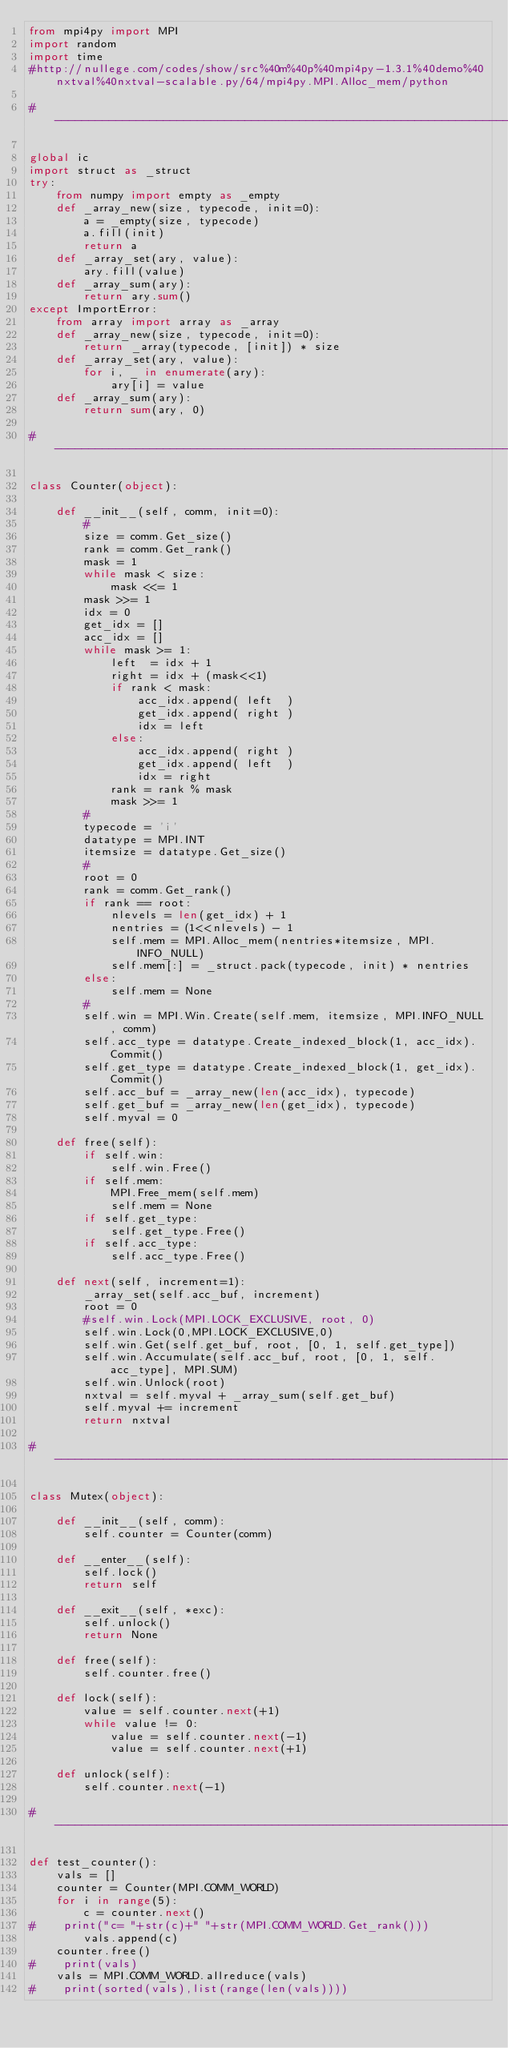Convert code to text. <code><loc_0><loc_0><loc_500><loc_500><_Python_>from mpi4py import MPI
import random
import time
#http://nullege.com/codes/show/src%40m%40p%40mpi4py-1.3.1%40demo%40nxtval%40nxtval-scalable.py/64/mpi4py.MPI.Alloc_mem/python
  
# -----------------------------------------------------------------------------
  
global ic
import struct as _struct
try:
    from numpy import empty as _empty
    def _array_new(size, typecode, init=0):
        a = _empty(size, typecode)
        a.fill(init)
        return a
    def _array_set(ary, value):
        ary.fill(value)
    def _array_sum(ary):
        return ary.sum()
except ImportError:
    from array import array as _array
    def _array_new(size, typecode, init=0):
        return _array(typecode, [init]) * size
    def _array_set(ary, value):
        for i, _ in enumerate(ary):
            ary[i] = value
    def _array_sum(ary):
        return sum(ary, 0)
  
# -----------------------------------------------------------------------------
  
class Counter(object):
  
    def __init__(self, comm, init=0):
        #
        size = comm.Get_size()
        rank = comm.Get_rank()
        mask = 1
        while mask < size:
            mask <<= 1
        mask >>= 1
        idx = 0
        get_idx = []
        acc_idx = []
        while mask >= 1:
            left  = idx + 1
            right = idx + (mask<<1)
            if rank < mask:
                acc_idx.append( left  )
                get_idx.append( right )
                idx = left
            else:
                acc_idx.append( right )
                get_idx.append( left  )
                idx = right
            rank = rank % mask
            mask >>= 1
        #
        typecode = 'i'
        datatype = MPI.INT
        itemsize = datatype.Get_size()
        #
        root = 0
        rank = comm.Get_rank()
        if rank == root:
            nlevels = len(get_idx) + 1
            nentries = (1<<nlevels) - 1
            self.mem = MPI.Alloc_mem(nentries*itemsize, MPI.INFO_NULL)
            self.mem[:] = _struct.pack(typecode, init) * nentries
        else:
            self.mem = None
        #
        self.win = MPI.Win.Create(self.mem, itemsize, MPI.INFO_NULL, comm)
        self.acc_type = datatype.Create_indexed_block(1, acc_idx).Commit()
        self.get_type = datatype.Create_indexed_block(1, get_idx).Commit()
        self.acc_buf = _array_new(len(acc_idx), typecode)
        self.get_buf = _array_new(len(get_idx), typecode)
        self.myval = 0
  
    def free(self):
        if self.win:
            self.win.Free()
        if self.mem:
            MPI.Free_mem(self.mem)
            self.mem = None
        if self.get_type:
            self.get_type.Free()
        if self.acc_type:
            self.acc_type.Free()
  
    def next(self, increment=1):
        _array_set(self.acc_buf, increment)
        root = 0
        #self.win.Lock(MPI.LOCK_EXCLUSIVE, root, 0)
        self.win.Lock(0,MPI.LOCK_EXCLUSIVE,0)
        self.win.Get(self.get_buf, root, [0, 1, self.get_type])
        self.win.Accumulate(self.acc_buf, root, [0, 1, self.acc_type], MPI.SUM)
        self.win.Unlock(root)
        nxtval = self.myval + _array_sum(self.get_buf)
        self.myval += increment
        return nxtval
  
# -----------------------------------------------------------------------------
  
class Mutex(object):
  
    def __init__(self, comm):
        self.counter = Counter(comm)
  
    def __enter__(self):
        self.lock()
        return self
  
    def __exit__(self, *exc):
        self.unlock()
        return None
  
    def free(self):
        self.counter.free()
  
    def lock(self):
        value = self.counter.next(+1)
        while value != 0:
            value = self.counter.next(-1)
            value = self.counter.next(+1)
  
    def unlock(self):
        self.counter.next(-1)
  
# -----------------------------------------------------------------------------
  
def test_counter():
    vals = []
    counter = Counter(MPI.COMM_WORLD)
    for i in range(5):
        c = counter.next()
#    print("c= "+str(c)+" "+str(MPI.COMM_WORLD.Get_rank()))
        vals.append(c)
    counter.free()
#    print(vals) 
    vals = MPI.COMM_WORLD.allreduce(vals)
#    print(sorted(vals),list(range(len(vals))))</code> 